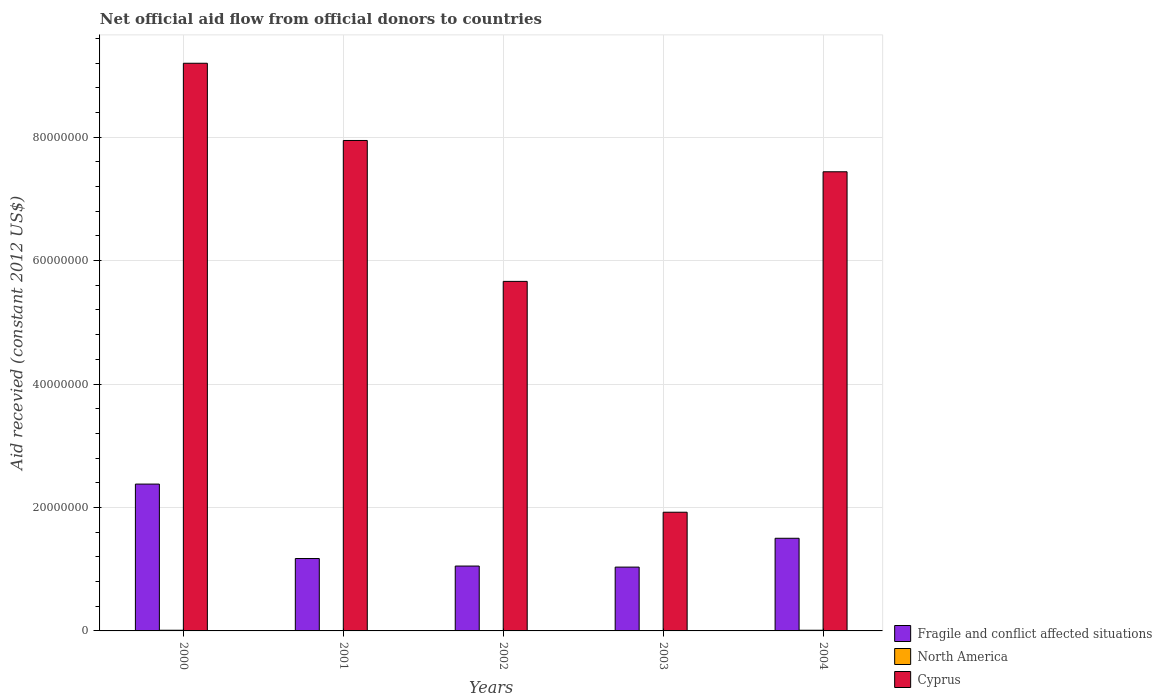How many different coloured bars are there?
Ensure brevity in your answer.  3. Are the number of bars per tick equal to the number of legend labels?
Provide a short and direct response. Yes. Are the number of bars on each tick of the X-axis equal?
Your response must be concise. Yes. How many bars are there on the 5th tick from the left?
Give a very brief answer. 3. What is the total aid received in Cyprus in 2003?
Your answer should be very brief. 1.92e+07. Across all years, what is the maximum total aid received in North America?
Offer a very short reply. 1.10e+05. Across all years, what is the minimum total aid received in North America?
Offer a terse response. 3.00e+04. In which year was the total aid received in Fragile and conflict affected situations maximum?
Your response must be concise. 2000. In which year was the total aid received in North America minimum?
Give a very brief answer. 2002. What is the total total aid received in Cyprus in the graph?
Provide a succinct answer. 3.22e+08. What is the difference between the total aid received in Fragile and conflict affected situations in 2001 and that in 2002?
Your answer should be compact. 1.22e+06. What is the difference between the total aid received in Fragile and conflict affected situations in 2003 and the total aid received in North America in 2002?
Offer a terse response. 1.03e+07. What is the average total aid received in North America per year?
Provide a succinct answer. 6.60e+04. In the year 2002, what is the difference between the total aid received in Cyprus and total aid received in Fragile and conflict affected situations?
Provide a short and direct response. 4.61e+07. In how many years, is the total aid received in Cyprus greater than 60000000 US$?
Provide a succinct answer. 3. What is the ratio of the total aid received in Cyprus in 2001 to that in 2003?
Make the answer very short. 4.13. Is the total aid received in Fragile and conflict affected situations in 2000 less than that in 2002?
Give a very brief answer. No. Is the difference between the total aid received in Cyprus in 2001 and 2002 greater than the difference between the total aid received in Fragile and conflict affected situations in 2001 and 2002?
Offer a very short reply. Yes. What is the difference between the highest and the second highest total aid received in North America?
Give a very brief answer. 0. What is the difference between the highest and the lowest total aid received in Cyprus?
Your answer should be compact. 7.27e+07. In how many years, is the total aid received in Fragile and conflict affected situations greater than the average total aid received in Fragile and conflict affected situations taken over all years?
Your answer should be very brief. 2. What does the 3rd bar from the left in 2002 represents?
Ensure brevity in your answer.  Cyprus. What does the 1st bar from the right in 2001 represents?
Keep it short and to the point. Cyprus. Are all the bars in the graph horizontal?
Ensure brevity in your answer.  No. What is the difference between two consecutive major ticks on the Y-axis?
Make the answer very short. 2.00e+07. Are the values on the major ticks of Y-axis written in scientific E-notation?
Your answer should be very brief. No. Where does the legend appear in the graph?
Provide a succinct answer. Bottom right. What is the title of the graph?
Offer a very short reply. Net official aid flow from official donors to countries. Does "Monaco" appear as one of the legend labels in the graph?
Keep it short and to the point. No. What is the label or title of the Y-axis?
Make the answer very short. Aid recevied (constant 2012 US$). What is the Aid recevied (constant 2012 US$) in Fragile and conflict affected situations in 2000?
Your response must be concise. 2.38e+07. What is the Aid recevied (constant 2012 US$) of Cyprus in 2000?
Keep it short and to the point. 9.20e+07. What is the Aid recevied (constant 2012 US$) of Fragile and conflict affected situations in 2001?
Offer a terse response. 1.17e+07. What is the Aid recevied (constant 2012 US$) in Cyprus in 2001?
Keep it short and to the point. 7.95e+07. What is the Aid recevied (constant 2012 US$) in Fragile and conflict affected situations in 2002?
Offer a terse response. 1.05e+07. What is the Aid recevied (constant 2012 US$) of Cyprus in 2002?
Provide a short and direct response. 5.66e+07. What is the Aid recevied (constant 2012 US$) in Fragile and conflict affected situations in 2003?
Offer a terse response. 1.03e+07. What is the Aid recevied (constant 2012 US$) of North America in 2003?
Your answer should be very brief. 4.00e+04. What is the Aid recevied (constant 2012 US$) of Cyprus in 2003?
Your answer should be compact. 1.92e+07. What is the Aid recevied (constant 2012 US$) in Fragile and conflict affected situations in 2004?
Provide a short and direct response. 1.50e+07. What is the Aid recevied (constant 2012 US$) in North America in 2004?
Give a very brief answer. 1.10e+05. What is the Aid recevied (constant 2012 US$) of Cyprus in 2004?
Your response must be concise. 7.44e+07. Across all years, what is the maximum Aid recevied (constant 2012 US$) in Fragile and conflict affected situations?
Provide a short and direct response. 2.38e+07. Across all years, what is the maximum Aid recevied (constant 2012 US$) of Cyprus?
Make the answer very short. 9.20e+07. Across all years, what is the minimum Aid recevied (constant 2012 US$) of Fragile and conflict affected situations?
Your answer should be very brief. 1.03e+07. Across all years, what is the minimum Aid recevied (constant 2012 US$) of Cyprus?
Offer a very short reply. 1.92e+07. What is the total Aid recevied (constant 2012 US$) in Fragile and conflict affected situations in the graph?
Make the answer very short. 7.14e+07. What is the total Aid recevied (constant 2012 US$) in North America in the graph?
Give a very brief answer. 3.30e+05. What is the total Aid recevied (constant 2012 US$) in Cyprus in the graph?
Make the answer very short. 3.22e+08. What is the difference between the Aid recevied (constant 2012 US$) of Fragile and conflict affected situations in 2000 and that in 2001?
Provide a short and direct response. 1.21e+07. What is the difference between the Aid recevied (constant 2012 US$) in North America in 2000 and that in 2001?
Your answer should be very brief. 7.00e+04. What is the difference between the Aid recevied (constant 2012 US$) in Cyprus in 2000 and that in 2001?
Make the answer very short. 1.25e+07. What is the difference between the Aid recevied (constant 2012 US$) in Fragile and conflict affected situations in 2000 and that in 2002?
Give a very brief answer. 1.33e+07. What is the difference between the Aid recevied (constant 2012 US$) in North America in 2000 and that in 2002?
Your answer should be very brief. 8.00e+04. What is the difference between the Aid recevied (constant 2012 US$) of Cyprus in 2000 and that in 2002?
Your response must be concise. 3.53e+07. What is the difference between the Aid recevied (constant 2012 US$) in Fragile and conflict affected situations in 2000 and that in 2003?
Your response must be concise. 1.34e+07. What is the difference between the Aid recevied (constant 2012 US$) in North America in 2000 and that in 2003?
Your answer should be compact. 7.00e+04. What is the difference between the Aid recevied (constant 2012 US$) of Cyprus in 2000 and that in 2003?
Your answer should be very brief. 7.27e+07. What is the difference between the Aid recevied (constant 2012 US$) of Fragile and conflict affected situations in 2000 and that in 2004?
Your response must be concise. 8.78e+06. What is the difference between the Aid recevied (constant 2012 US$) of Cyprus in 2000 and that in 2004?
Your answer should be compact. 1.76e+07. What is the difference between the Aid recevied (constant 2012 US$) in Fragile and conflict affected situations in 2001 and that in 2002?
Give a very brief answer. 1.22e+06. What is the difference between the Aid recevied (constant 2012 US$) of North America in 2001 and that in 2002?
Provide a succinct answer. 10000. What is the difference between the Aid recevied (constant 2012 US$) of Cyprus in 2001 and that in 2002?
Provide a short and direct response. 2.28e+07. What is the difference between the Aid recevied (constant 2012 US$) of Fragile and conflict affected situations in 2001 and that in 2003?
Offer a terse response. 1.39e+06. What is the difference between the Aid recevied (constant 2012 US$) of Cyprus in 2001 and that in 2003?
Your response must be concise. 6.02e+07. What is the difference between the Aid recevied (constant 2012 US$) in Fragile and conflict affected situations in 2001 and that in 2004?
Provide a short and direct response. -3.28e+06. What is the difference between the Aid recevied (constant 2012 US$) in Cyprus in 2001 and that in 2004?
Provide a succinct answer. 5.07e+06. What is the difference between the Aid recevied (constant 2012 US$) in Fragile and conflict affected situations in 2002 and that in 2003?
Offer a terse response. 1.70e+05. What is the difference between the Aid recevied (constant 2012 US$) in North America in 2002 and that in 2003?
Ensure brevity in your answer.  -10000. What is the difference between the Aid recevied (constant 2012 US$) in Cyprus in 2002 and that in 2003?
Give a very brief answer. 3.74e+07. What is the difference between the Aid recevied (constant 2012 US$) of Fragile and conflict affected situations in 2002 and that in 2004?
Your response must be concise. -4.50e+06. What is the difference between the Aid recevied (constant 2012 US$) in Cyprus in 2002 and that in 2004?
Offer a very short reply. -1.78e+07. What is the difference between the Aid recevied (constant 2012 US$) of Fragile and conflict affected situations in 2003 and that in 2004?
Ensure brevity in your answer.  -4.67e+06. What is the difference between the Aid recevied (constant 2012 US$) of Cyprus in 2003 and that in 2004?
Keep it short and to the point. -5.52e+07. What is the difference between the Aid recevied (constant 2012 US$) of Fragile and conflict affected situations in 2000 and the Aid recevied (constant 2012 US$) of North America in 2001?
Offer a terse response. 2.38e+07. What is the difference between the Aid recevied (constant 2012 US$) in Fragile and conflict affected situations in 2000 and the Aid recevied (constant 2012 US$) in Cyprus in 2001?
Offer a terse response. -5.57e+07. What is the difference between the Aid recevied (constant 2012 US$) of North America in 2000 and the Aid recevied (constant 2012 US$) of Cyprus in 2001?
Provide a short and direct response. -7.94e+07. What is the difference between the Aid recevied (constant 2012 US$) of Fragile and conflict affected situations in 2000 and the Aid recevied (constant 2012 US$) of North America in 2002?
Offer a very short reply. 2.38e+07. What is the difference between the Aid recevied (constant 2012 US$) in Fragile and conflict affected situations in 2000 and the Aid recevied (constant 2012 US$) in Cyprus in 2002?
Provide a succinct answer. -3.28e+07. What is the difference between the Aid recevied (constant 2012 US$) of North America in 2000 and the Aid recevied (constant 2012 US$) of Cyprus in 2002?
Offer a terse response. -5.65e+07. What is the difference between the Aid recevied (constant 2012 US$) in Fragile and conflict affected situations in 2000 and the Aid recevied (constant 2012 US$) in North America in 2003?
Give a very brief answer. 2.38e+07. What is the difference between the Aid recevied (constant 2012 US$) in Fragile and conflict affected situations in 2000 and the Aid recevied (constant 2012 US$) in Cyprus in 2003?
Offer a very short reply. 4.56e+06. What is the difference between the Aid recevied (constant 2012 US$) of North America in 2000 and the Aid recevied (constant 2012 US$) of Cyprus in 2003?
Ensure brevity in your answer.  -1.91e+07. What is the difference between the Aid recevied (constant 2012 US$) of Fragile and conflict affected situations in 2000 and the Aid recevied (constant 2012 US$) of North America in 2004?
Offer a very short reply. 2.37e+07. What is the difference between the Aid recevied (constant 2012 US$) in Fragile and conflict affected situations in 2000 and the Aid recevied (constant 2012 US$) in Cyprus in 2004?
Ensure brevity in your answer.  -5.06e+07. What is the difference between the Aid recevied (constant 2012 US$) in North America in 2000 and the Aid recevied (constant 2012 US$) in Cyprus in 2004?
Your response must be concise. -7.43e+07. What is the difference between the Aid recevied (constant 2012 US$) of Fragile and conflict affected situations in 2001 and the Aid recevied (constant 2012 US$) of North America in 2002?
Make the answer very short. 1.17e+07. What is the difference between the Aid recevied (constant 2012 US$) of Fragile and conflict affected situations in 2001 and the Aid recevied (constant 2012 US$) of Cyprus in 2002?
Provide a short and direct response. -4.49e+07. What is the difference between the Aid recevied (constant 2012 US$) of North America in 2001 and the Aid recevied (constant 2012 US$) of Cyprus in 2002?
Keep it short and to the point. -5.66e+07. What is the difference between the Aid recevied (constant 2012 US$) in Fragile and conflict affected situations in 2001 and the Aid recevied (constant 2012 US$) in North America in 2003?
Give a very brief answer. 1.17e+07. What is the difference between the Aid recevied (constant 2012 US$) in Fragile and conflict affected situations in 2001 and the Aid recevied (constant 2012 US$) in Cyprus in 2003?
Provide a short and direct response. -7.50e+06. What is the difference between the Aid recevied (constant 2012 US$) of North America in 2001 and the Aid recevied (constant 2012 US$) of Cyprus in 2003?
Keep it short and to the point. -1.92e+07. What is the difference between the Aid recevied (constant 2012 US$) in Fragile and conflict affected situations in 2001 and the Aid recevied (constant 2012 US$) in North America in 2004?
Provide a short and direct response. 1.16e+07. What is the difference between the Aid recevied (constant 2012 US$) of Fragile and conflict affected situations in 2001 and the Aid recevied (constant 2012 US$) of Cyprus in 2004?
Your answer should be very brief. -6.27e+07. What is the difference between the Aid recevied (constant 2012 US$) of North America in 2001 and the Aid recevied (constant 2012 US$) of Cyprus in 2004?
Your answer should be very brief. -7.44e+07. What is the difference between the Aid recevied (constant 2012 US$) of Fragile and conflict affected situations in 2002 and the Aid recevied (constant 2012 US$) of North America in 2003?
Offer a very short reply. 1.05e+07. What is the difference between the Aid recevied (constant 2012 US$) of Fragile and conflict affected situations in 2002 and the Aid recevied (constant 2012 US$) of Cyprus in 2003?
Provide a succinct answer. -8.72e+06. What is the difference between the Aid recevied (constant 2012 US$) in North America in 2002 and the Aid recevied (constant 2012 US$) in Cyprus in 2003?
Give a very brief answer. -1.92e+07. What is the difference between the Aid recevied (constant 2012 US$) in Fragile and conflict affected situations in 2002 and the Aid recevied (constant 2012 US$) in North America in 2004?
Offer a terse response. 1.04e+07. What is the difference between the Aid recevied (constant 2012 US$) of Fragile and conflict affected situations in 2002 and the Aid recevied (constant 2012 US$) of Cyprus in 2004?
Your response must be concise. -6.39e+07. What is the difference between the Aid recevied (constant 2012 US$) in North America in 2002 and the Aid recevied (constant 2012 US$) in Cyprus in 2004?
Ensure brevity in your answer.  -7.44e+07. What is the difference between the Aid recevied (constant 2012 US$) of Fragile and conflict affected situations in 2003 and the Aid recevied (constant 2012 US$) of North America in 2004?
Make the answer very short. 1.02e+07. What is the difference between the Aid recevied (constant 2012 US$) in Fragile and conflict affected situations in 2003 and the Aid recevied (constant 2012 US$) in Cyprus in 2004?
Provide a succinct answer. -6.40e+07. What is the difference between the Aid recevied (constant 2012 US$) in North America in 2003 and the Aid recevied (constant 2012 US$) in Cyprus in 2004?
Provide a short and direct response. -7.44e+07. What is the average Aid recevied (constant 2012 US$) in Fragile and conflict affected situations per year?
Your answer should be compact. 1.43e+07. What is the average Aid recevied (constant 2012 US$) in North America per year?
Keep it short and to the point. 6.60e+04. What is the average Aid recevied (constant 2012 US$) of Cyprus per year?
Give a very brief answer. 6.43e+07. In the year 2000, what is the difference between the Aid recevied (constant 2012 US$) in Fragile and conflict affected situations and Aid recevied (constant 2012 US$) in North America?
Offer a terse response. 2.37e+07. In the year 2000, what is the difference between the Aid recevied (constant 2012 US$) in Fragile and conflict affected situations and Aid recevied (constant 2012 US$) in Cyprus?
Provide a succinct answer. -6.82e+07. In the year 2000, what is the difference between the Aid recevied (constant 2012 US$) in North America and Aid recevied (constant 2012 US$) in Cyprus?
Your answer should be very brief. -9.19e+07. In the year 2001, what is the difference between the Aid recevied (constant 2012 US$) of Fragile and conflict affected situations and Aid recevied (constant 2012 US$) of North America?
Your answer should be very brief. 1.17e+07. In the year 2001, what is the difference between the Aid recevied (constant 2012 US$) in Fragile and conflict affected situations and Aid recevied (constant 2012 US$) in Cyprus?
Give a very brief answer. -6.77e+07. In the year 2001, what is the difference between the Aid recevied (constant 2012 US$) in North America and Aid recevied (constant 2012 US$) in Cyprus?
Your answer should be compact. -7.94e+07. In the year 2002, what is the difference between the Aid recevied (constant 2012 US$) in Fragile and conflict affected situations and Aid recevied (constant 2012 US$) in North America?
Give a very brief answer. 1.05e+07. In the year 2002, what is the difference between the Aid recevied (constant 2012 US$) in Fragile and conflict affected situations and Aid recevied (constant 2012 US$) in Cyprus?
Your response must be concise. -4.61e+07. In the year 2002, what is the difference between the Aid recevied (constant 2012 US$) in North America and Aid recevied (constant 2012 US$) in Cyprus?
Keep it short and to the point. -5.66e+07. In the year 2003, what is the difference between the Aid recevied (constant 2012 US$) in Fragile and conflict affected situations and Aid recevied (constant 2012 US$) in North America?
Offer a terse response. 1.03e+07. In the year 2003, what is the difference between the Aid recevied (constant 2012 US$) in Fragile and conflict affected situations and Aid recevied (constant 2012 US$) in Cyprus?
Your answer should be compact. -8.89e+06. In the year 2003, what is the difference between the Aid recevied (constant 2012 US$) in North America and Aid recevied (constant 2012 US$) in Cyprus?
Give a very brief answer. -1.92e+07. In the year 2004, what is the difference between the Aid recevied (constant 2012 US$) of Fragile and conflict affected situations and Aid recevied (constant 2012 US$) of North America?
Provide a succinct answer. 1.49e+07. In the year 2004, what is the difference between the Aid recevied (constant 2012 US$) of Fragile and conflict affected situations and Aid recevied (constant 2012 US$) of Cyprus?
Offer a terse response. -5.94e+07. In the year 2004, what is the difference between the Aid recevied (constant 2012 US$) in North America and Aid recevied (constant 2012 US$) in Cyprus?
Provide a succinct answer. -7.43e+07. What is the ratio of the Aid recevied (constant 2012 US$) of Fragile and conflict affected situations in 2000 to that in 2001?
Give a very brief answer. 2.03. What is the ratio of the Aid recevied (constant 2012 US$) in North America in 2000 to that in 2001?
Offer a very short reply. 2.75. What is the ratio of the Aid recevied (constant 2012 US$) of Cyprus in 2000 to that in 2001?
Offer a very short reply. 1.16. What is the ratio of the Aid recevied (constant 2012 US$) of Fragile and conflict affected situations in 2000 to that in 2002?
Offer a very short reply. 2.26. What is the ratio of the Aid recevied (constant 2012 US$) of North America in 2000 to that in 2002?
Your response must be concise. 3.67. What is the ratio of the Aid recevied (constant 2012 US$) in Cyprus in 2000 to that in 2002?
Keep it short and to the point. 1.62. What is the ratio of the Aid recevied (constant 2012 US$) in Fragile and conflict affected situations in 2000 to that in 2003?
Provide a short and direct response. 2.3. What is the ratio of the Aid recevied (constant 2012 US$) in North America in 2000 to that in 2003?
Provide a succinct answer. 2.75. What is the ratio of the Aid recevied (constant 2012 US$) of Cyprus in 2000 to that in 2003?
Keep it short and to the point. 4.78. What is the ratio of the Aid recevied (constant 2012 US$) of Fragile and conflict affected situations in 2000 to that in 2004?
Provide a succinct answer. 1.58. What is the ratio of the Aid recevied (constant 2012 US$) in Cyprus in 2000 to that in 2004?
Provide a succinct answer. 1.24. What is the ratio of the Aid recevied (constant 2012 US$) of Fragile and conflict affected situations in 2001 to that in 2002?
Offer a terse response. 1.12. What is the ratio of the Aid recevied (constant 2012 US$) of Cyprus in 2001 to that in 2002?
Make the answer very short. 1.4. What is the ratio of the Aid recevied (constant 2012 US$) of Fragile and conflict affected situations in 2001 to that in 2003?
Your response must be concise. 1.13. What is the ratio of the Aid recevied (constant 2012 US$) of Cyprus in 2001 to that in 2003?
Ensure brevity in your answer.  4.13. What is the ratio of the Aid recevied (constant 2012 US$) in Fragile and conflict affected situations in 2001 to that in 2004?
Ensure brevity in your answer.  0.78. What is the ratio of the Aid recevied (constant 2012 US$) in North America in 2001 to that in 2004?
Your answer should be compact. 0.36. What is the ratio of the Aid recevied (constant 2012 US$) of Cyprus in 2001 to that in 2004?
Keep it short and to the point. 1.07. What is the ratio of the Aid recevied (constant 2012 US$) of Fragile and conflict affected situations in 2002 to that in 2003?
Offer a very short reply. 1.02. What is the ratio of the Aid recevied (constant 2012 US$) of North America in 2002 to that in 2003?
Give a very brief answer. 0.75. What is the ratio of the Aid recevied (constant 2012 US$) in Cyprus in 2002 to that in 2003?
Keep it short and to the point. 2.94. What is the ratio of the Aid recevied (constant 2012 US$) of Fragile and conflict affected situations in 2002 to that in 2004?
Your answer should be very brief. 0.7. What is the ratio of the Aid recevied (constant 2012 US$) in North America in 2002 to that in 2004?
Provide a short and direct response. 0.27. What is the ratio of the Aid recevied (constant 2012 US$) in Cyprus in 2002 to that in 2004?
Provide a succinct answer. 0.76. What is the ratio of the Aid recevied (constant 2012 US$) in Fragile and conflict affected situations in 2003 to that in 2004?
Your response must be concise. 0.69. What is the ratio of the Aid recevied (constant 2012 US$) of North America in 2003 to that in 2004?
Offer a very short reply. 0.36. What is the ratio of the Aid recevied (constant 2012 US$) in Cyprus in 2003 to that in 2004?
Provide a short and direct response. 0.26. What is the difference between the highest and the second highest Aid recevied (constant 2012 US$) of Fragile and conflict affected situations?
Your response must be concise. 8.78e+06. What is the difference between the highest and the second highest Aid recevied (constant 2012 US$) in Cyprus?
Ensure brevity in your answer.  1.25e+07. What is the difference between the highest and the lowest Aid recevied (constant 2012 US$) of Fragile and conflict affected situations?
Your answer should be compact. 1.34e+07. What is the difference between the highest and the lowest Aid recevied (constant 2012 US$) of Cyprus?
Provide a short and direct response. 7.27e+07. 